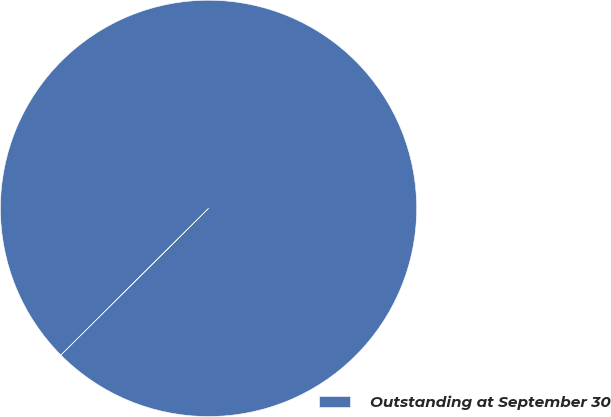Convert chart. <chart><loc_0><loc_0><loc_500><loc_500><pie_chart><fcel>Outstanding at September 30<nl><fcel>100.0%<nl></chart> 